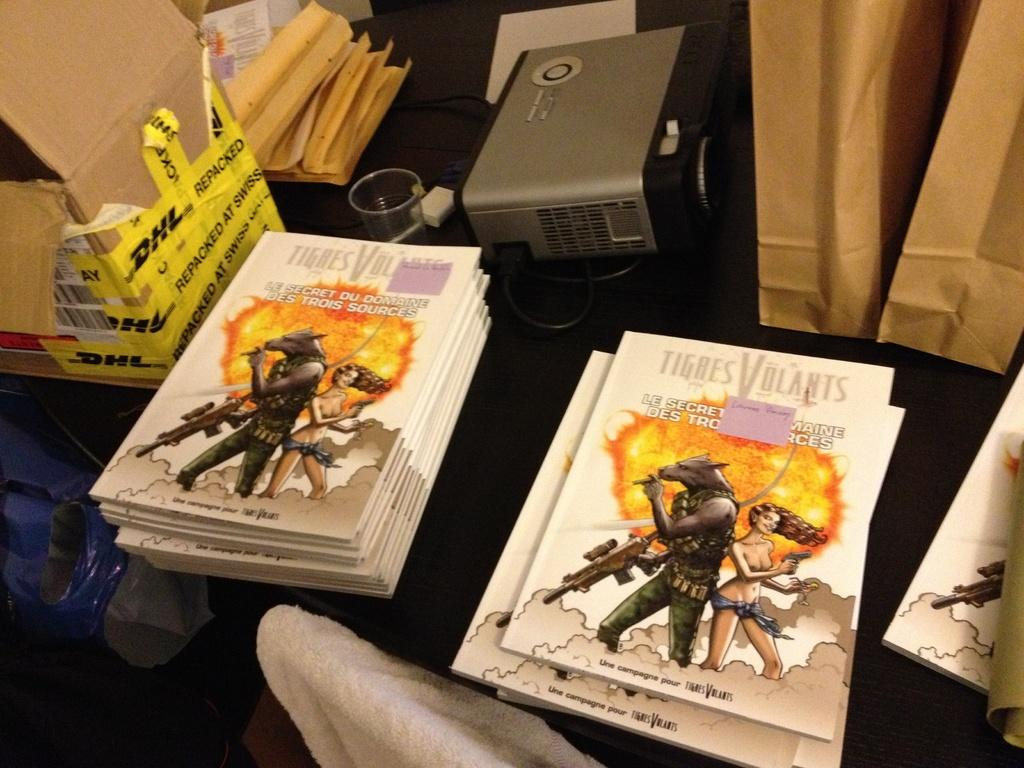<image>
Provide a brief description of the given image. a few books that have the word tigres on them 